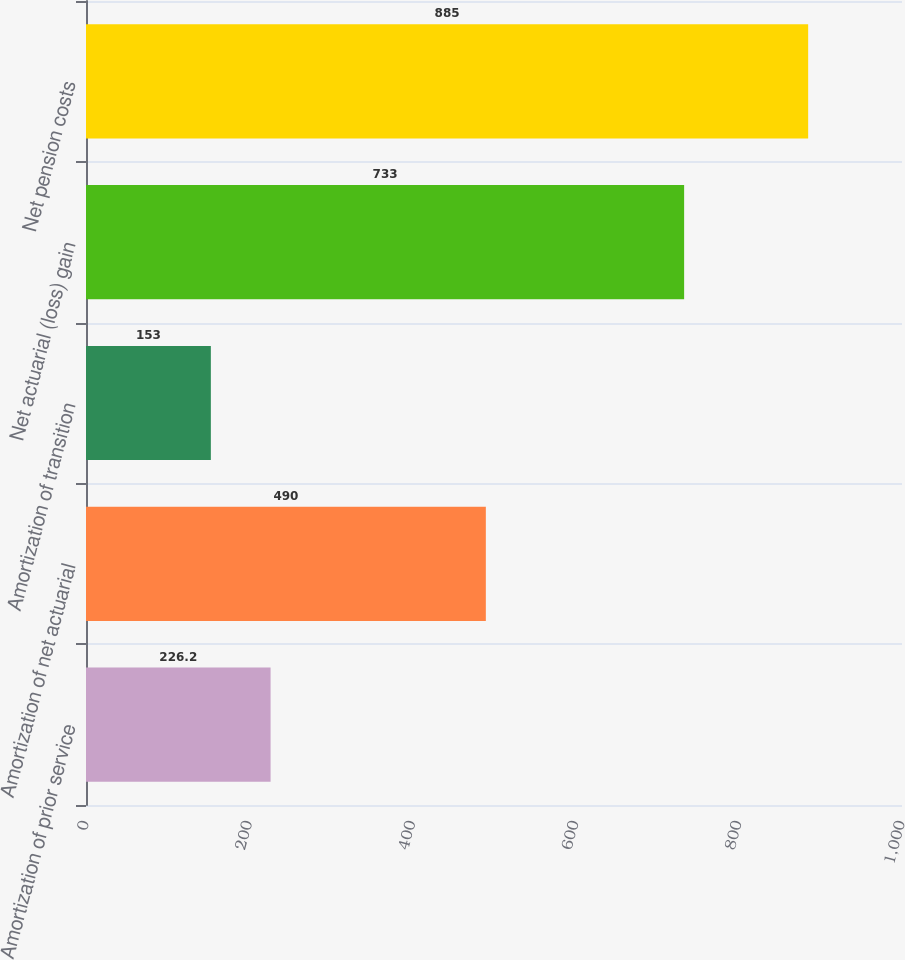Convert chart to OTSL. <chart><loc_0><loc_0><loc_500><loc_500><bar_chart><fcel>Amortization of prior service<fcel>Amortization of net actuarial<fcel>Amortization of transition<fcel>Net actuarial (loss) gain<fcel>Net pension costs<nl><fcel>226.2<fcel>490<fcel>153<fcel>733<fcel>885<nl></chart> 